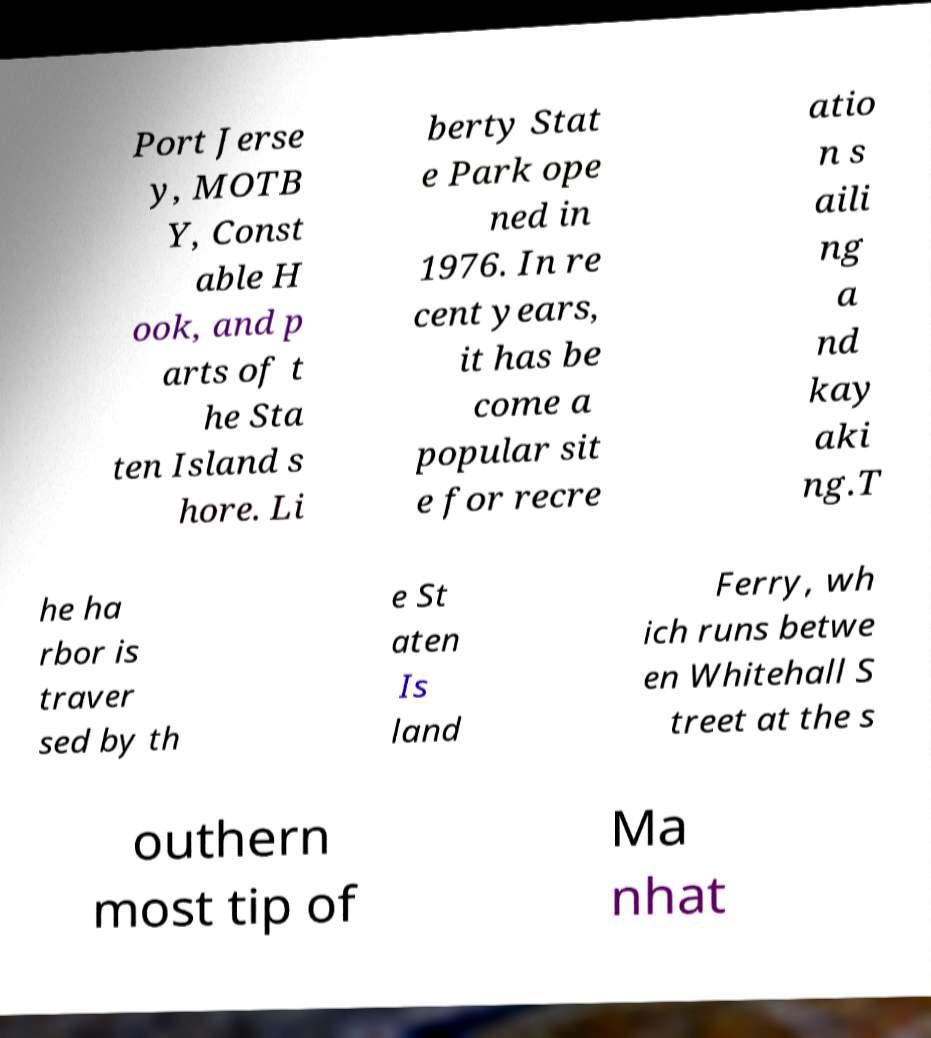Can you accurately transcribe the text from the provided image for me? Port Jerse y, MOTB Y, Const able H ook, and p arts of t he Sta ten Island s hore. Li berty Stat e Park ope ned in 1976. In re cent years, it has be come a popular sit e for recre atio n s aili ng a nd kay aki ng.T he ha rbor is traver sed by th e St aten Is land Ferry, wh ich runs betwe en Whitehall S treet at the s outhern most tip of Ma nhat 